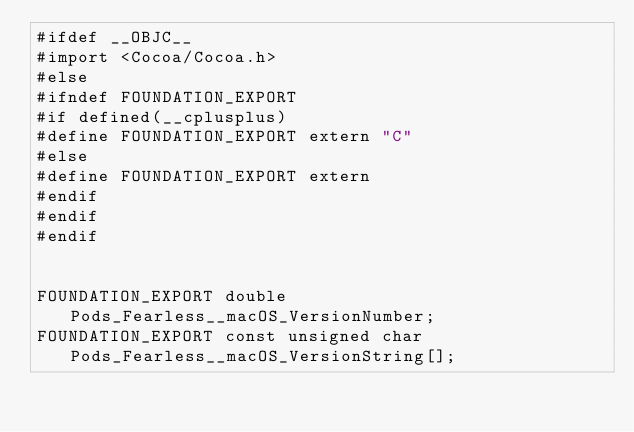Convert code to text. <code><loc_0><loc_0><loc_500><loc_500><_C_>#ifdef __OBJC__
#import <Cocoa/Cocoa.h>
#else
#ifndef FOUNDATION_EXPORT
#if defined(__cplusplus)
#define FOUNDATION_EXPORT extern "C"
#else
#define FOUNDATION_EXPORT extern
#endif
#endif
#endif


FOUNDATION_EXPORT double Pods_Fearless__macOS_VersionNumber;
FOUNDATION_EXPORT const unsigned char Pods_Fearless__macOS_VersionString[];

</code> 